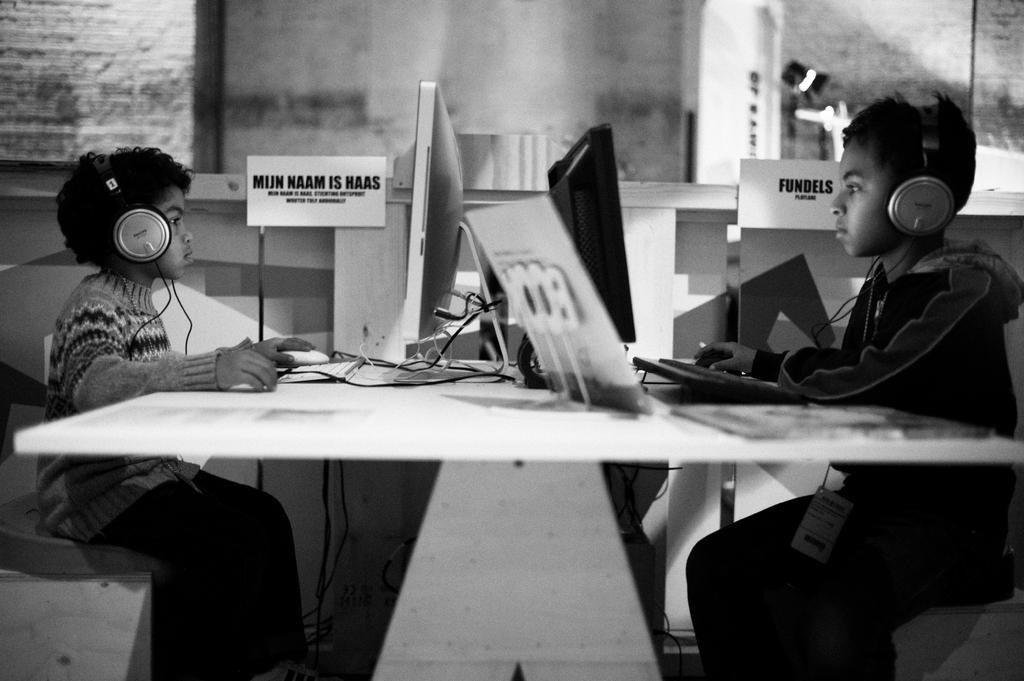How would you summarize this image in a sentence or two? As we can see in the image there is a laptop and a table, poster and two people sitting on chairs. 